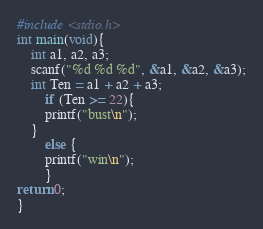<code> <loc_0><loc_0><loc_500><loc_500><_C_>#include <stdio.h>
int main(void){
    int a1, a2, a3;
    scanf("%d %d %d", &a1, &a2, &a3);
    int Ten = a1 + a2 + a3;
        if (Ten >= 22){
        printf("bust\n");
    }
        else {
        printf("win\n");
        }
return 0;
}</code> 